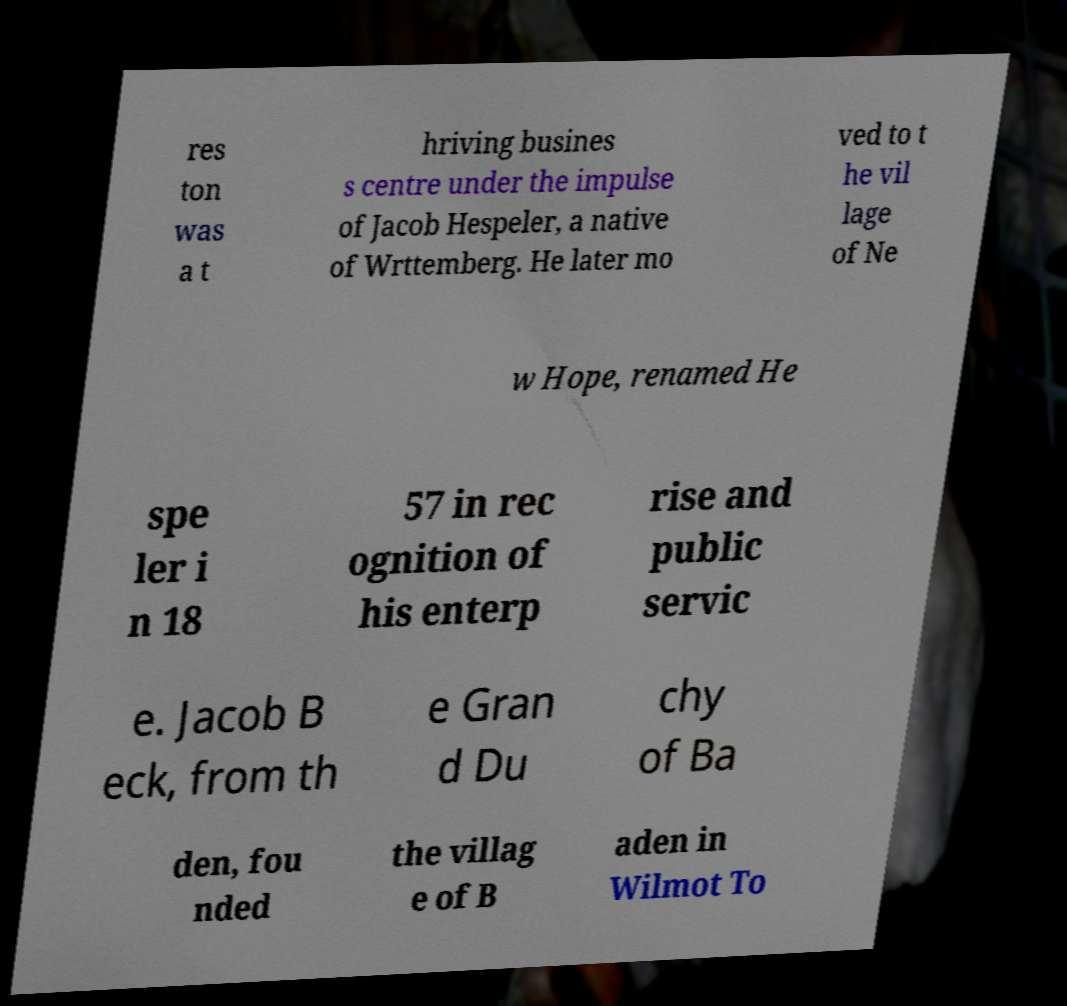I need the written content from this picture converted into text. Can you do that? res ton was a t hriving busines s centre under the impulse of Jacob Hespeler, a native of Wrttemberg. He later mo ved to t he vil lage of Ne w Hope, renamed He spe ler i n 18 57 in rec ognition of his enterp rise and public servic e. Jacob B eck, from th e Gran d Du chy of Ba den, fou nded the villag e of B aden in Wilmot To 